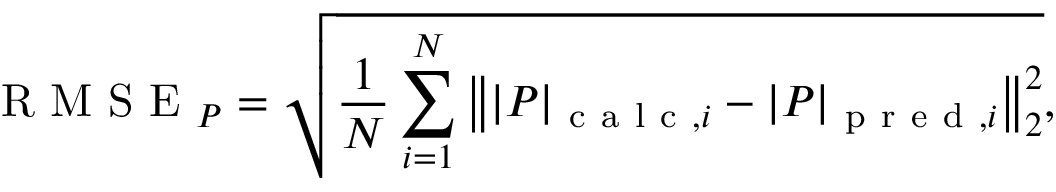<formula> <loc_0><loc_0><loc_500><loc_500>R M S E _ { P } = \sqrt { \frac { 1 } { N } \sum _ { i = 1 } ^ { N } \left \| | P | _ { c a l c , i } - | P | _ { p r e d , i } \right \| _ { 2 } ^ { 2 } } ,</formula> 